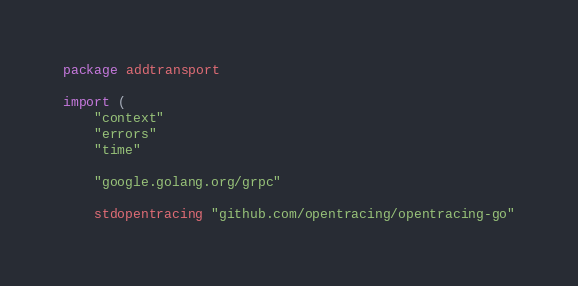Convert code to text. <code><loc_0><loc_0><loc_500><loc_500><_Go_>package addtransport

import (
	"context"
	"errors"
	"time"

	"google.golang.org/grpc"

	stdopentracing "github.com/opentracing/opentracing-go"</code> 